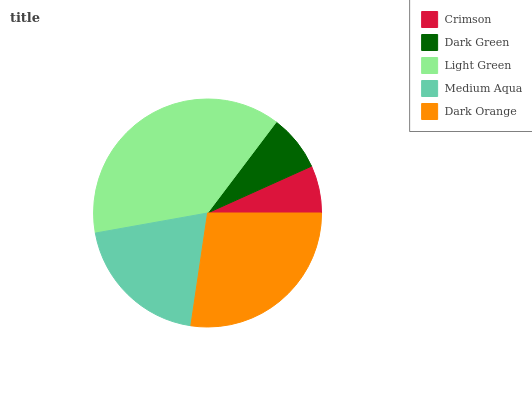Is Crimson the minimum?
Answer yes or no. Yes. Is Light Green the maximum?
Answer yes or no. Yes. Is Dark Green the minimum?
Answer yes or no. No. Is Dark Green the maximum?
Answer yes or no. No. Is Dark Green greater than Crimson?
Answer yes or no. Yes. Is Crimson less than Dark Green?
Answer yes or no. Yes. Is Crimson greater than Dark Green?
Answer yes or no. No. Is Dark Green less than Crimson?
Answer yes or no. No. Is Medium Aqua the high median?
Answer yes or no. Yes. Is Medium Aqua the low median?
Answer yes or no. Yes. Is Crimson the high median?
Answer yes or no. No. Is Crimson the low median?
Answer yes or no. No. 